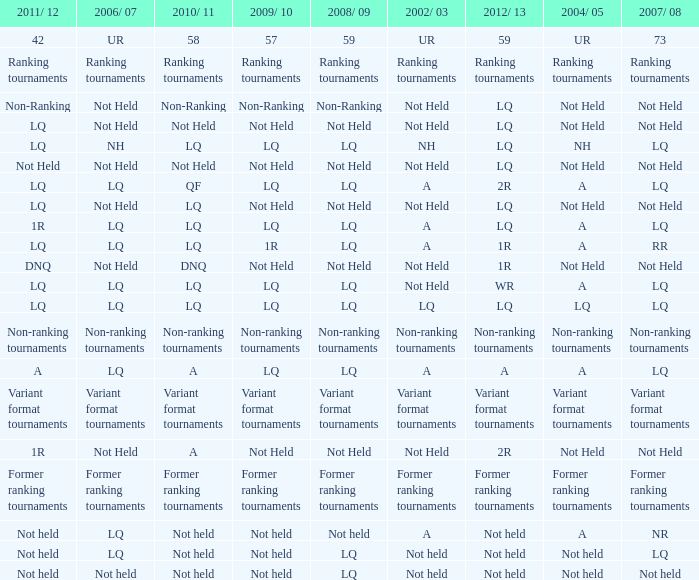Name the 2008/09 with 2004/05 of ranking tournaments Ranking tournaments. 